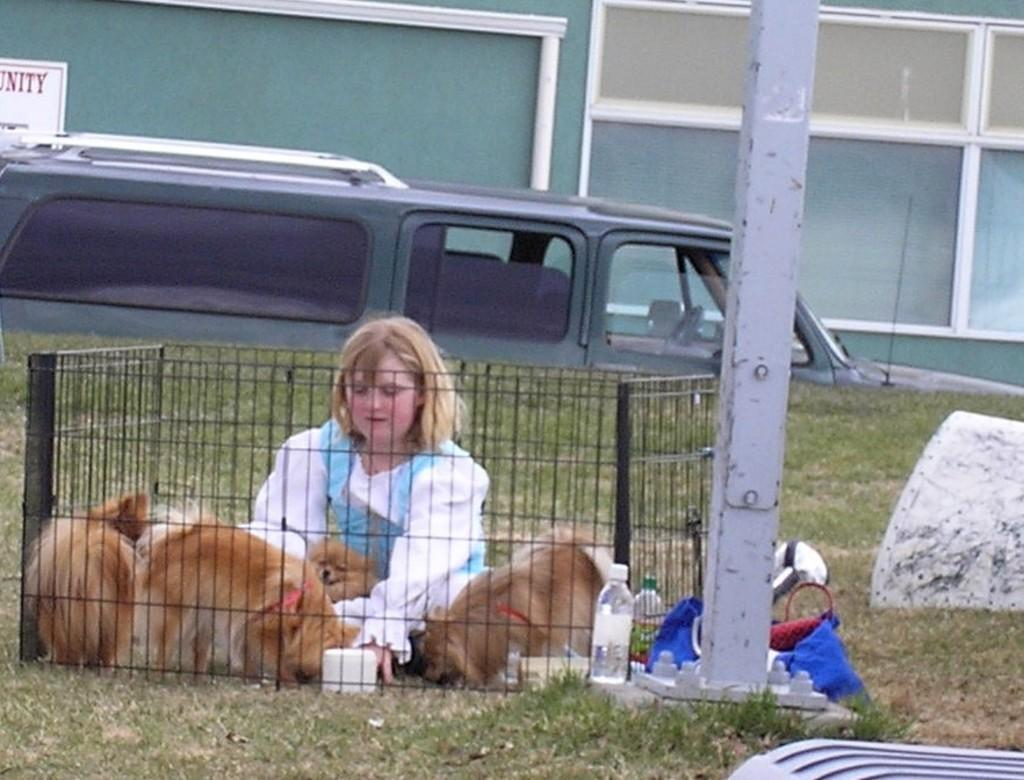What type of vegetation can be seen in the foreground of the picture? There is grass in the foreground of the picture. What objects are present in the foreground of the picture? There is a water bottle, a bag, an iron pole, a cage, a girl, and dogs in the foreground of the picture. What can be seen in the background of the picture? There are vehicles in the background of the picture. What type of structure is visible at the top of the picture? There is a building at the top of the picture. How many geese are present in the picture? There are no geese present in the picture. What type of insurance is being discussed in the picture? There is no discussion of insurance in the picture. 